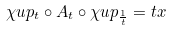Convert formula to latex. <formula><loc_0><loc_0><loc_500><loc_500>\chi u p _ { t } \circ A _ { t } \circ \chi u p _ { \frac { 1 } { t } } = t x</formula> 